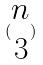Convert formula to latex. <formula><loc_0><loc_0><loc_500><loc_500>( \begin{matrix} n \\ 3 \end{matrix} )</formula> 